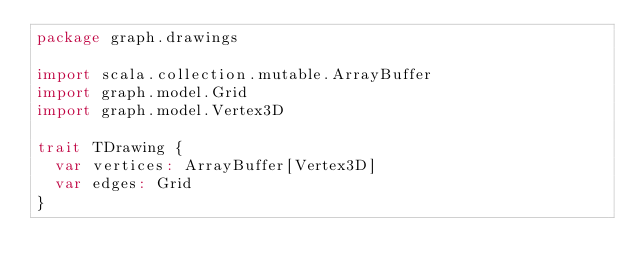Convert code to text. <code><loc_0><loc_0><loc_500><loc_500><_Scala_>package graph.drawings

import scala.collection.mutable.ArrayBuffer
import graph.model.Grid
import graph.model.Vertex3D

trait TDrawing {
  var vertices: ArrayBuffer[Vertex3D]
  var edges: Grid
}

</code> 